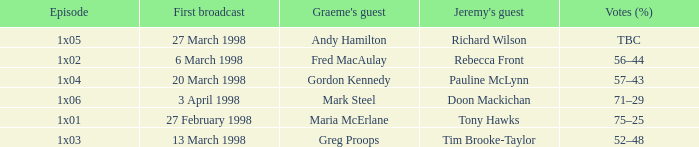What is Votes (%), when Episode is "1x03"? 52–48. 